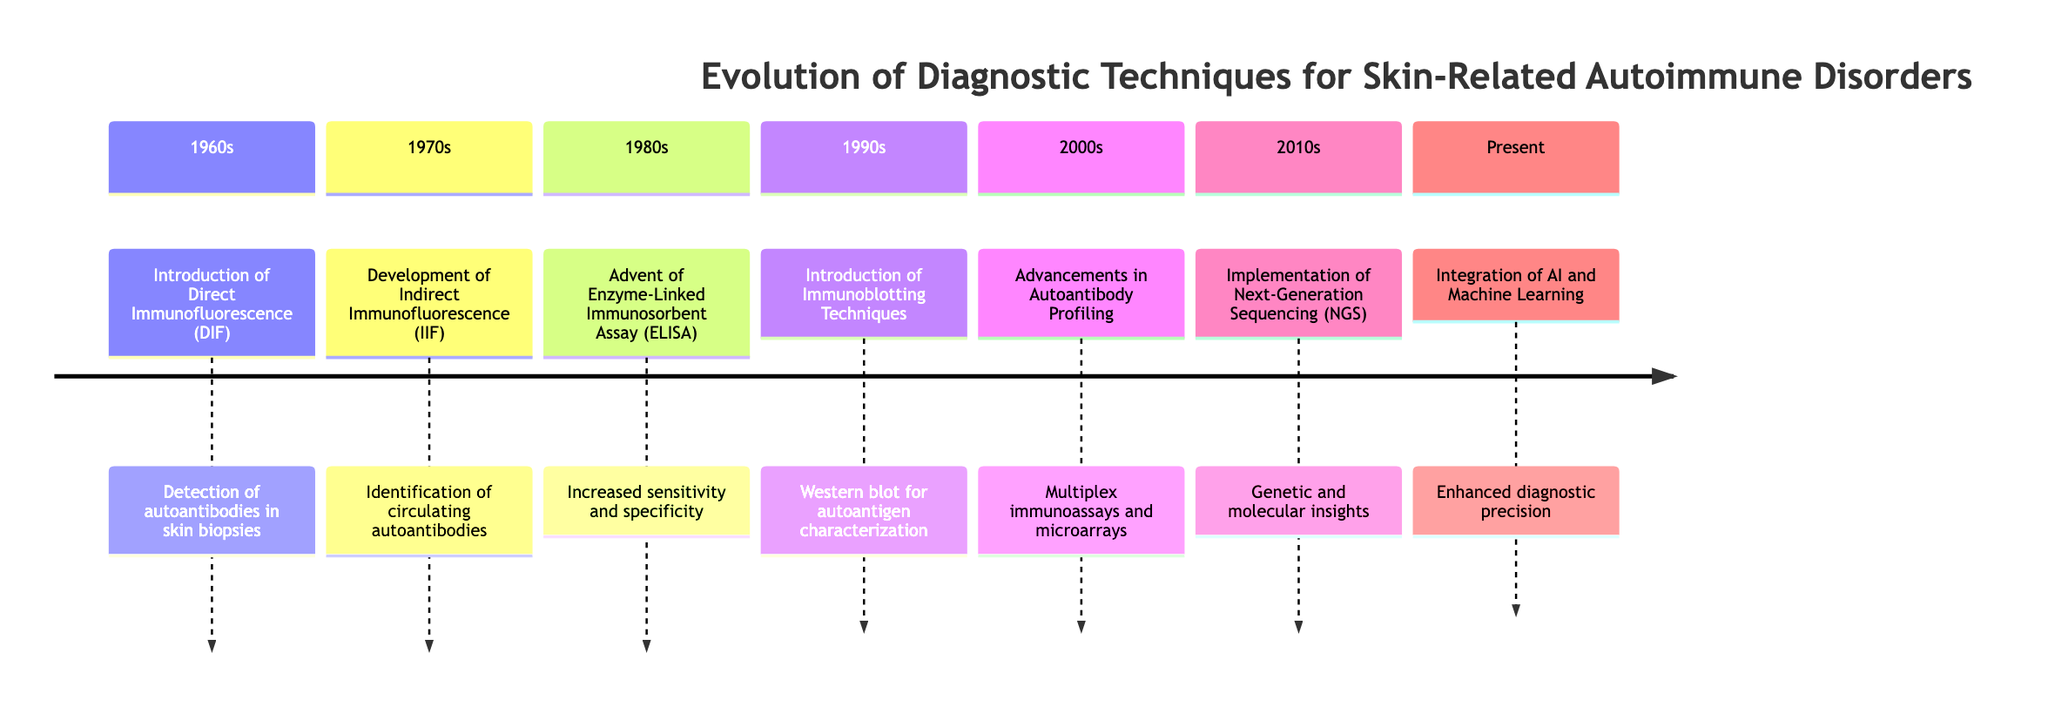What diagnostic technique was introduced in the 1960s? The timeline explicitly states that the introduction of Direct Immunofluorescence (DIF) occurred in the 1960s, making it the diagnostic technique highlighted for that period.
Answer: Direct Immunofluorescence (DIF) How many diagnostic techniques were introduced by the 1980s? By the 1980s, the timeline highlights the introduction of three distinct diagnostic techniques: Direct Immunofluorescence (1960s), Indirect Immunofluorescence (1970s), and Enzyme-Linked Immunosorbent Assay (1980s). Thus, the total is three techniques.
Answer: 3 What is the main advancement in the 2000s? The 2000s section mentions advancements in Autoantibody Profiling, specifically focusing on multiplex immunoassays and microarrays, indicating the primary development during this decade.
Answer: Advancements in Autoantibody Profiling Which decade saw the advent of Next-Generation Sequencing (NGS)? The timeline indicates that Next-Generation Sequencing (NGS) was implemented in the 2010s. Therefore, 2010s is the decade when this technique became prominent.
Answer: 2010s What diagnostic technique improves sensitivity and specificity? The advent of the Enzyme-Linked Immunosorbent Assay (ELISA) in the 1980s is stated to have increased sensitivity and specificity in autoimmune disorder diagnostics, highlighting its significance.
Answer: Enzyme-Linked Immunosorbent Assay (ELISA) Which technology aids in pattern recognition for diagnosing skin disorders? The timeline specifies that the integration of Artificial Intelligence (AI) and Machine Learning (ML) enhances diagnostic precision and assists in pattern recognition, indicating their crucial role in the current period.
Answer: Artificial Intelligence (AI) and Machine Learning (ML) Which technique was primarily utilized to identify circulating autoantibodies in the 1970s? According to the timeline, the technique developed in the 1970s for identifying circulating autoantibodies is Indirect Immunofluorescence (IIF). This is confirmed by the description associated with that section.
Answer: Indirect Immunofluorescence (IIF) What was the purpose of immunoblotting introduced in the 1990s? The 1990s section notes the introduction of immunoblotting techniques for identifying and characterizing specific autoantigens in autoimmune skin disorders, making its purpose clear within that context.
Answer: Identify and characterize specific autoantigens 